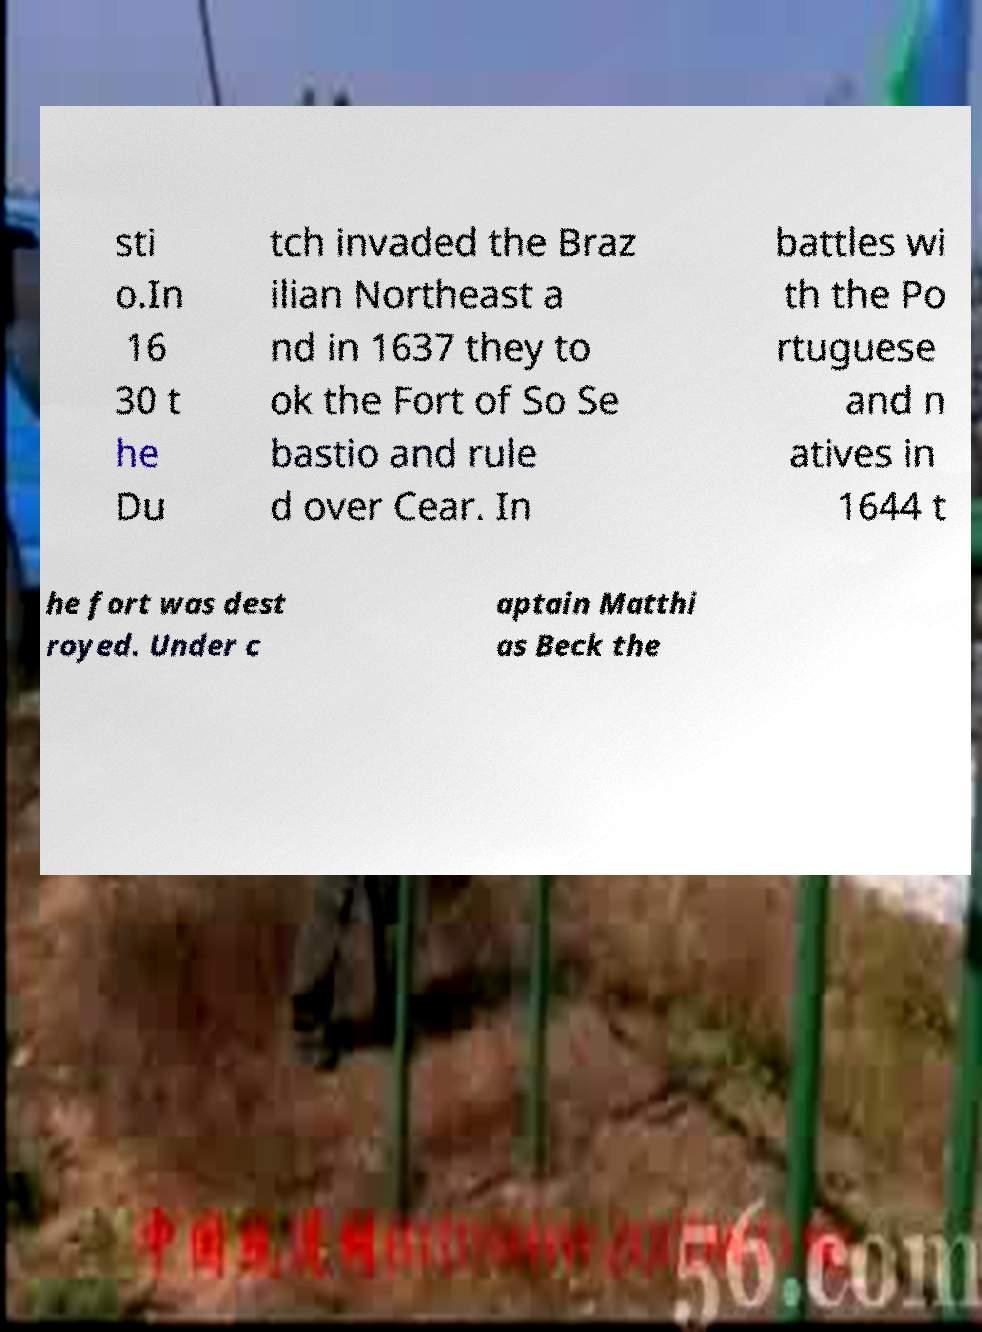Can you read and provide the text displayed in the image?This photo seems to have some interesting text. Can you extract and type it out for me? sti o.In 16 30 t he Du tch invaded the Braz ilian Northeast a nd in 1637 they to ok the Fort of So Se bastio and rule d over Cear. In battles wi th the Po rtuguese and n atives in 1644 t he fort was dest royed. Under c aptain Matthi as Beck the 